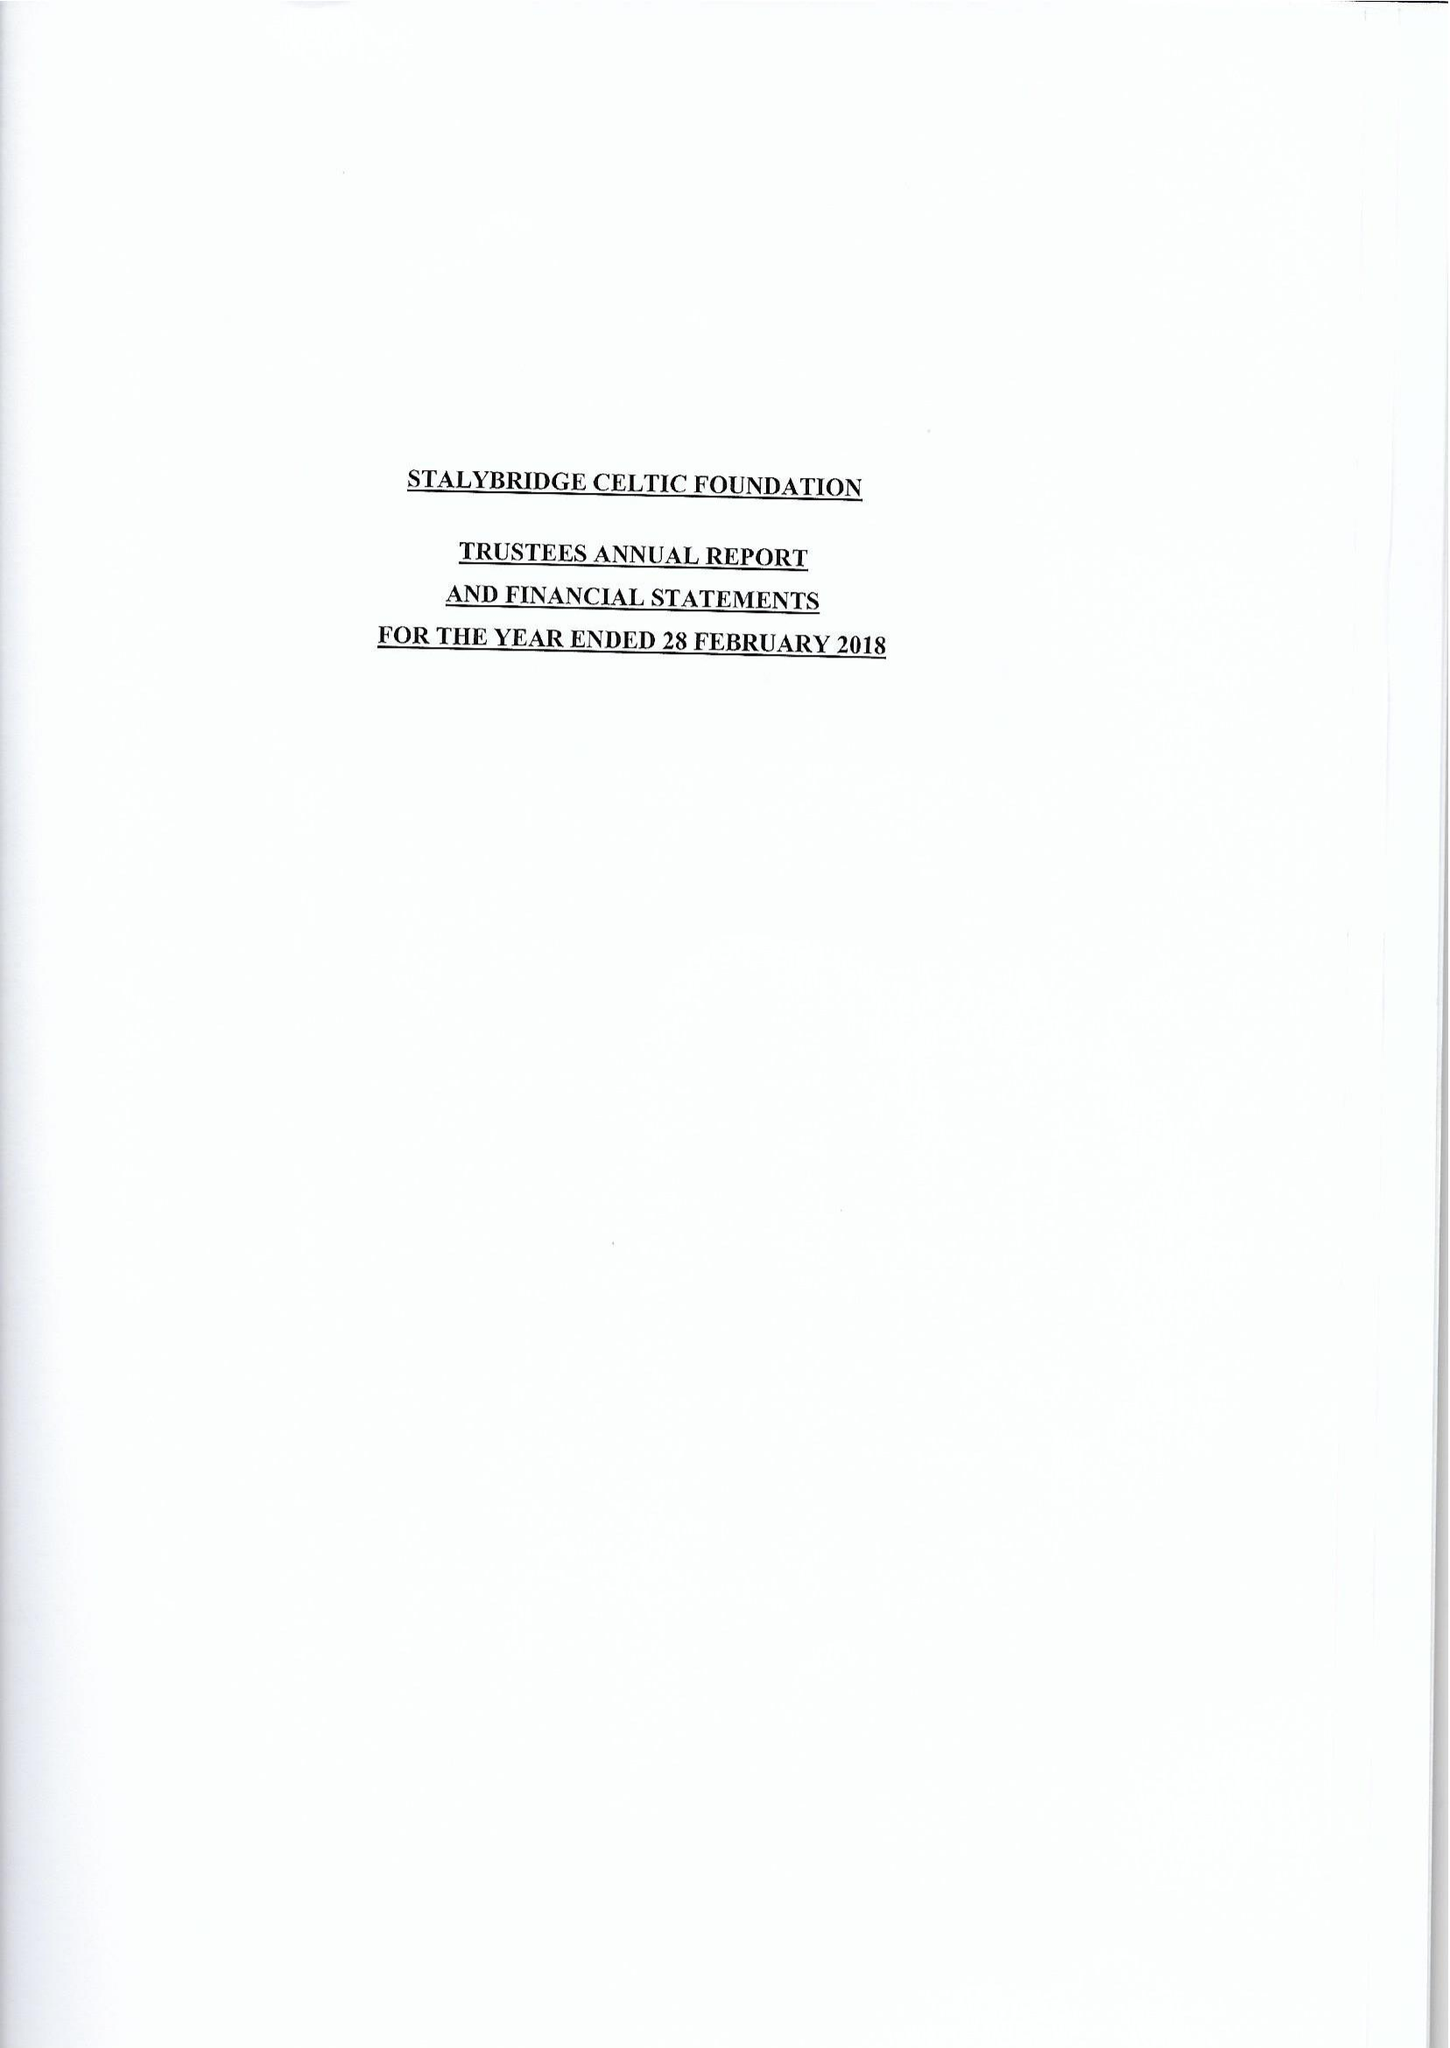What is the value for the report_date?
Answer the question using a single word or phrase. 2018-02-28 